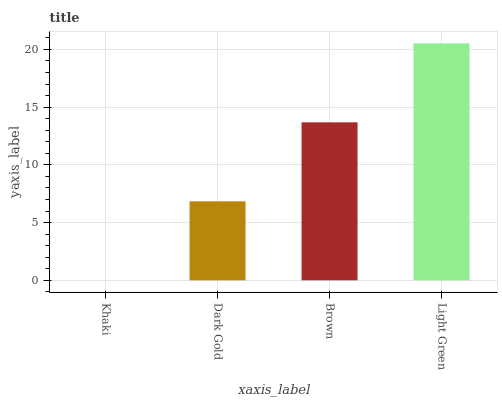Is Khaki the minimum?
Answer yes or no. Yes. Is Light Green the maximum?
Answer yes or no. Yes. Is Dark Gold the minimum?
Answer yes or no. No. Is Dark Gold the maximum?
Answer yes or no. No. Is Dark Gold greater than Khaki?
Answer yes or no. Yes. Is Khaki less than Dark Gold?
Answer yes or no. Yes. Is Khaki greater than Dark Gold?
Answer yes or no. No. Is Dark Gold less than Khaki?
Answer yes or no. No. Is Brown the high median?
Answer yes or no. Yes. Is Dark Gold the low median?
Answer yes or no. Yes. Is Light Green the high median?
Answer yes or no. No. Is Light Green the low median?
Answer yes or no. No. 